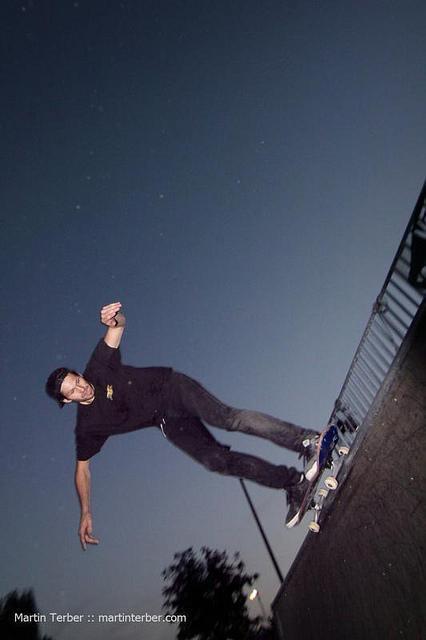How many wheels on the skateboard are in the air?
Give a very brief answer. 0. How many baby elephants are there?
Give a very brief answer. 0. 